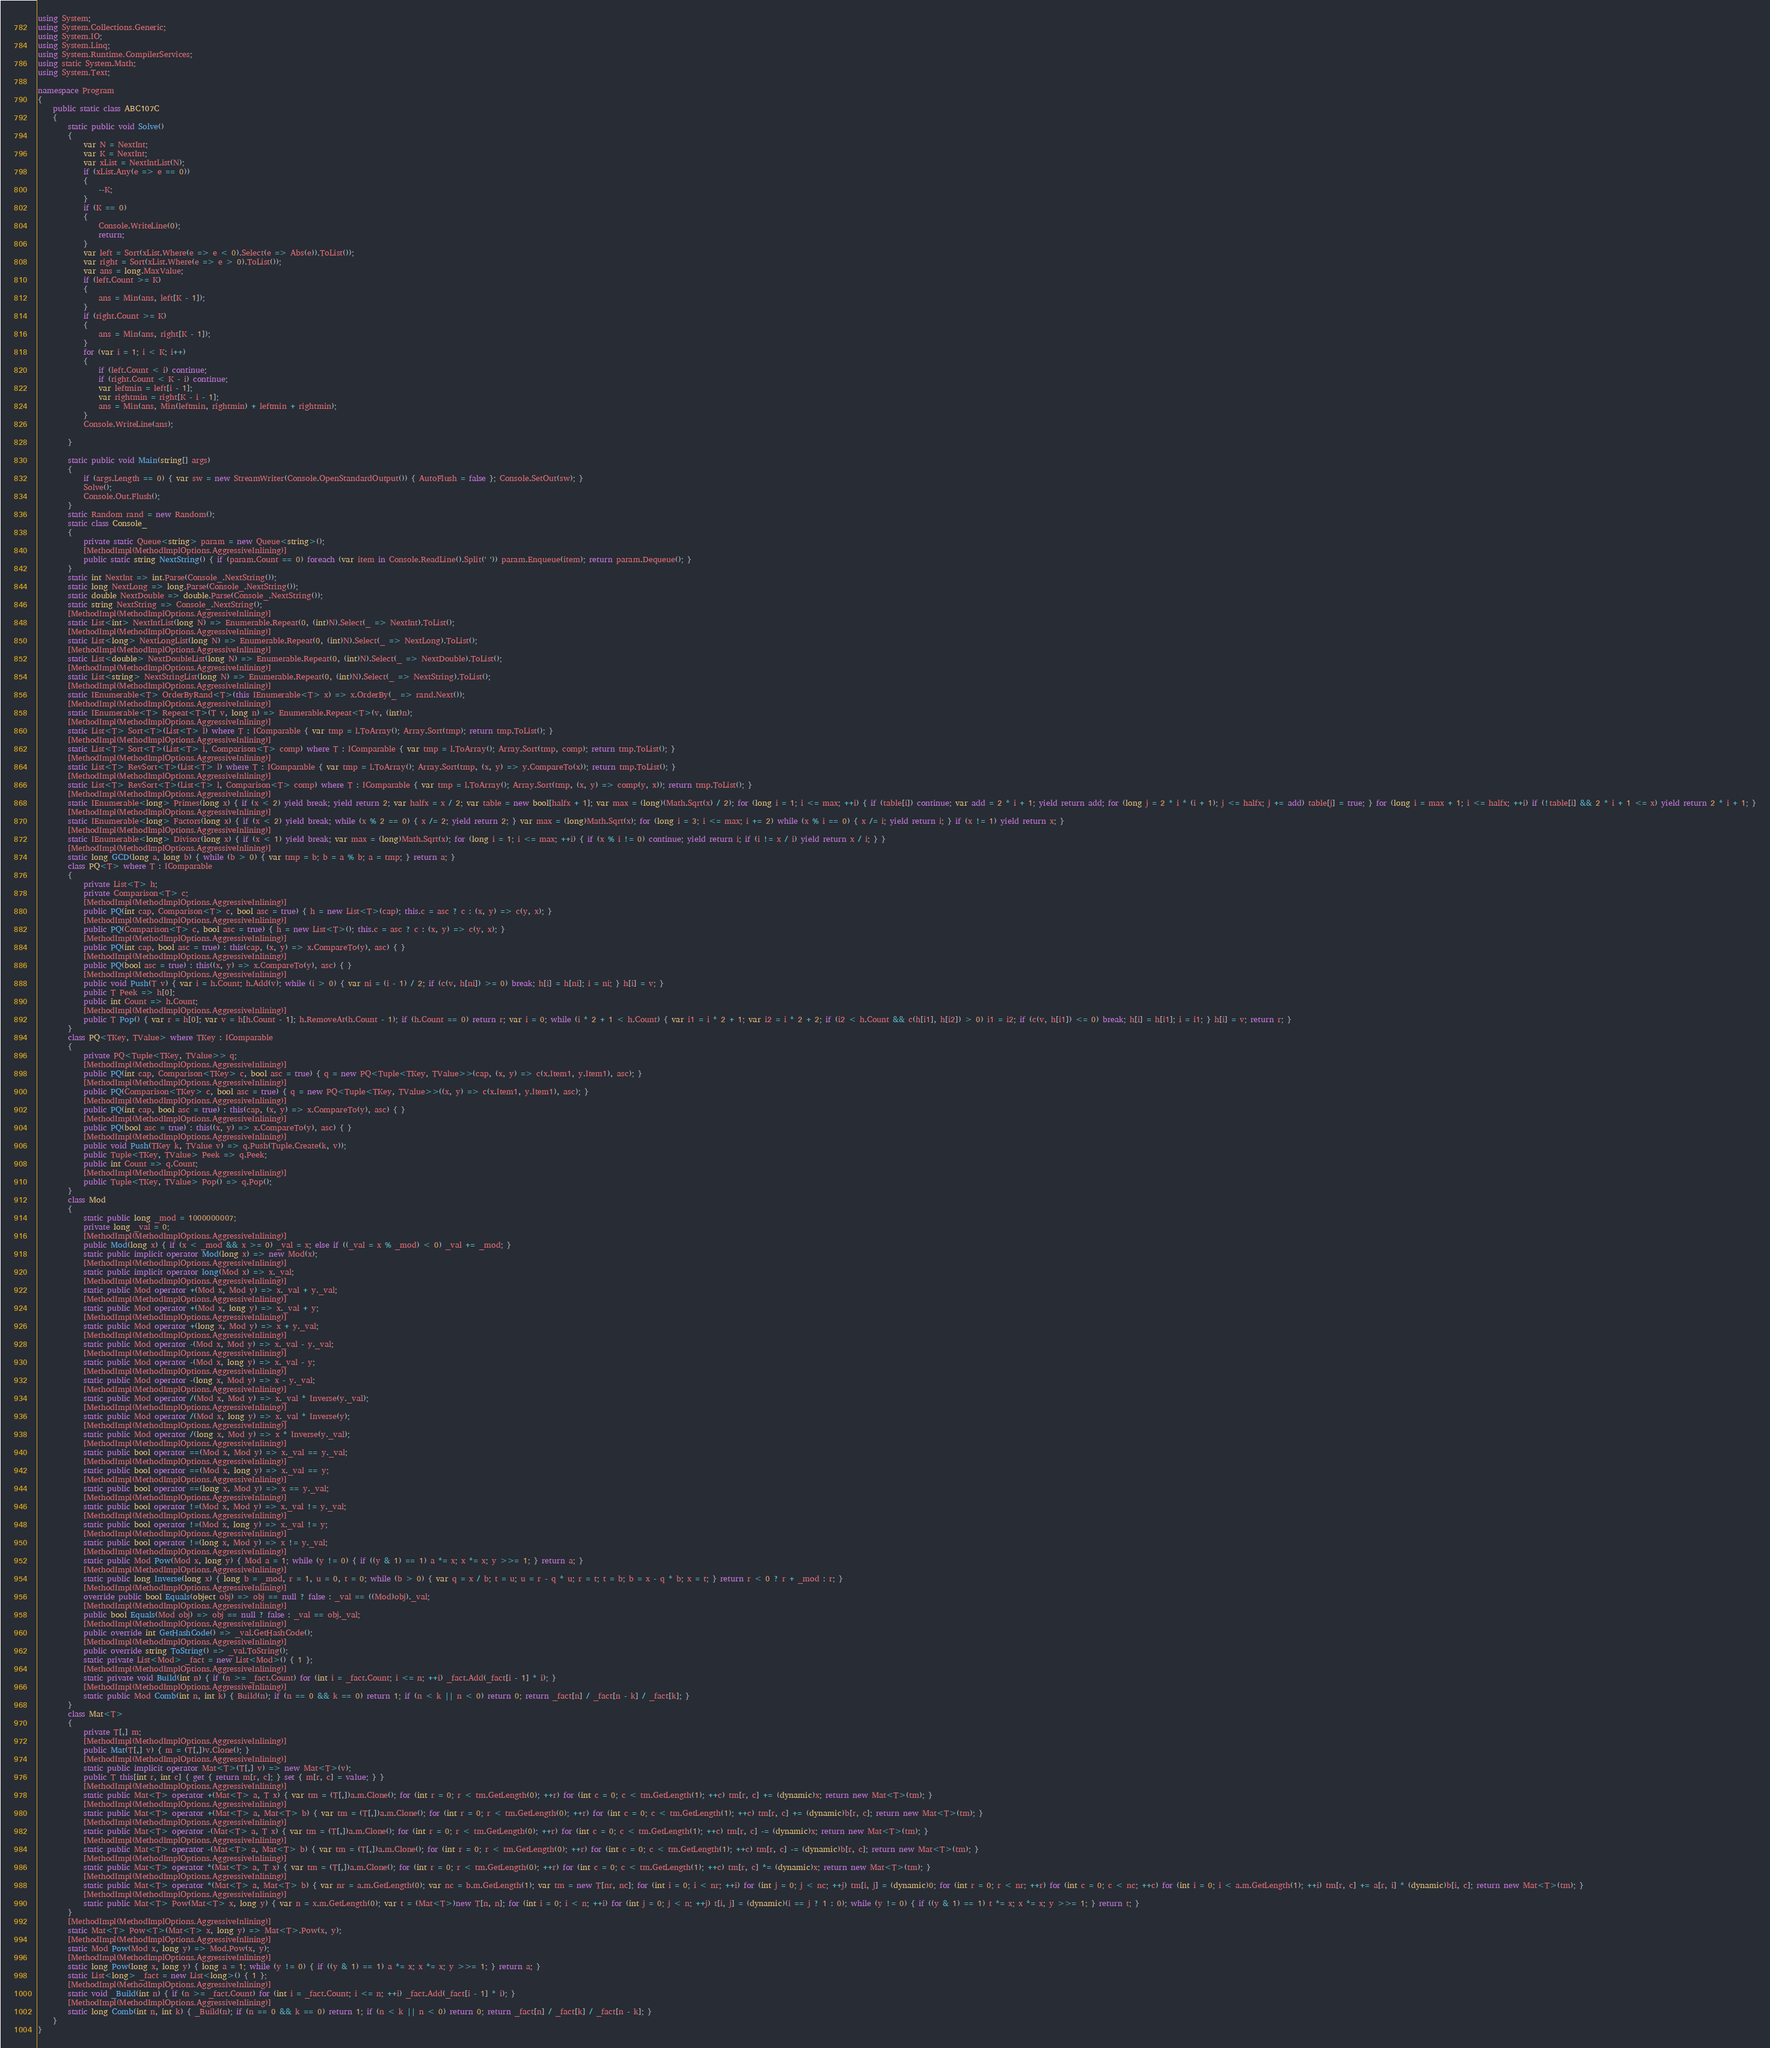Convert code to text. <code><loc_0><loc_0><loc_500><loc_500><_C#_>using System;
using System.Collections.Generic;
using System.IO;
using System.Linq;
using System.Runtime.CompilerServices;
using static System.Math;
using System.Text;

namespace Program
{
    public static class ABC107C
    {
        static public void Solve()
        {
            var N = NextInt;
            var K = NextInt;
            var xList = NextIntList(N);
            if (xList.Any(e => e == 0))
            {
                --K;
            }
            if (K == 0)
            {
                Console.WriteLine(0);
                return;
            }
            var left = Sort(xList.Where(e => e < 0).Select(e => Abs(e)).ToList());
            var right = Sort(xList.Where(e => e > 0).ToList());
            var ans = long.MaxValue;
            if (left.Count >= K)
            {
                ans = Min(ans, left[K - 1]);
            }
            if (right.Count >= K)
            {
                ans = Min(ans, right[K - 1]);
            }
            for (var i = 1; i < K; i++)
            {
                if (left.Count < i) continue;
                if (right.Count < K - i) continue;
                var leftmin = left[i - 1];
                var rightmin = right[K - i - 1];
                ans = Min(ans, Min(leftmin, rightmin) + leftmin + rightmin);
            }
            Console.WriteLine(ans);

        }

        static public void Main(string[] args)
        {
            if (args.Length == 0) { var sw = new StreamWriter(Console.OpenStandardOutput()) { AutoFlush = false }; Console.SetOut(sw); }
            Solve();
            Console.Out.Flush();
        }
        static Random rand = new Random();
        static class Console_
        {
            private static Queue<string> param = new Queue<string>();
            [MethodImpl(MethodImplOptions.AggressiveInlining)]
            public static string NextString() { if (param.Count == 0) foreach (var item in Console.ReadLine().Split(' ')) param.Enqueue(item); return param.Dequeue(); }
        }
        static int NextInt => int.Parse(Console_.NextString());
        static long NextLong => long.Parse(Console_.NextString());
        static double NextDouble => double.Parse(Console_.NextString());
        static string NextString => Console_.NextString();
        [MethodImpl(MethodImplOptions.AggressiveInlining)]
        static List<int> NextIntList(long N) => Enumerable.Repeat(0, (int)N).Select(_ => NextInt).ToList();
        [MethodImpl(MethodImplOptions.AggressiveInlining)]
        static List<long> NextLongList(long N) => Enumerable.Repeat(0, (int)N).Select(_ => NextLong).ToList();
        [MethodImpl(MethodImplOptions.AggressiveInlining)]
        static List<double> NextDoubleList(long N) => Enumerable.Repeat(0, (int)N).Select(_ => NextDouble).ToList();
        [MethodImpl(MethodImplOptions.AggressiveInlining)]
        static List<string> NextStringList(long N) => Enumerable.Repeat(0, (int)N).Select(_ => NextString).ToList();
        [MethodImpl(MethodImplOptions.AggressiveInlining)]
        static IEnumerable<T> OrderByRand<T>(this IEnumerable<T> x) => x.OrderBy(_ => rand.Next());
        [MethodImpl(MethodImplOptions.AggressiveInlining)]
        static IEnumerable<T> Repeat<T>(T v, long n) => Enumerable.Repeat<T>(v, (int)n);
        [MethodImpl(MethodImplOptions.AggressiveInlining)]
        static List<T> Sort<T>(List<T> l) where T : IComparable { var tmp = l.ToArray(); Array.Sort(tmp); return tmp.ToList(); }
        [MethodImpl(MethodImplOptions.AggressiveInlining)]
        static List<T> Sort<T>(List<T> l, Comparison<T> comp) where T : IComparable { var tmp = l.ToArray(); Array.Sort(tmp, comp); return tmp.ToList(); }
        [MethodImpl(MethodImplOptions.AggressiveInlining)]
        static List<T> RevSort<T>(List<T> l) where T : IComparable { var tmp = l.ToArray(); Array.Sort(tmp, (x, y) => y.CompareTo(x)); return tmp.ToList(); }
        [MethodImpl(MethodImplOptions.AggressiveInlining)]
        static List<T> RevSort<T>(List<T> l, Comparison<T> comp) where T : IComparable { var tmp = l.ToArray(); Array.Sort(tmp, (x, y) => comp(y, x)); return tmp.ToList(); }
        [MethodImpl(MethodImplOptions.AggressiveInlining)]
        static IEnumerable<long> Primes(long x) { if (x < 2) yield break; yield return 2; var halfx = x / 2; var table = new bool[halfx + 1]; var max = (long)(Math.Sqrt(x) / 2); for (long i = 1; i <= max; ++i) { if (table[i]) continue; var add = 2 * i + 1; yield return add; for (long j = 2 * i * (i + 1); j <= halfx; j += add) table[j] = true; } for (long i = max + 1; i <= halfx; ++i) if (!table[i] && 2 * i + 1 <= x) yield return 2 * i + 1; }
        [MethodImpl(MethodImplOptions.AggressiveInlining)]
        static IEnumerable<long> Factors(long x) { if (x < 2) yield break; while (x % 2 == 0) { x /= 2; yield return 2; } var max = (long)Math.Sqrt(x); for (long i = 3; i <= max; i += 2) while (x % i == 0) { x /= i; yield return i; } if (x != 1) yield return x; }
        [MethodImpl(MethodImplOptions.AggressiveInlining)]
        static IEnumerable<long> Divisor(long x) { if (x < 1) yield break; var max = (long)Math.Sqrt(x); for (long i = 1; i <= max; ++i) { if (x % i != 0) continue; yield return i; if (i != x / i) yield return x / i; } }
        [MethodImpl(MethodImplOptions.AggressiveInlining)]
        static long GCD(long a, long b) { while (b > 0) { var tmp = b; b = a % b; a = tmp; } return a; }
        class PQ<T> where T : IComparable
        {
            private List<T> h;
            private Comparison<T> c;
            [MethodImpl(MethodImplOptions.AggressiveInlining)]
            public PQ(int cap, Comparison<T> c, bool asc = true) { h = new List<T>(cap); this.c = asc ? c : (x, y) => c(y, x); }
            [MethodImpl(MethodImplOptions.AggressiveInlining)]
            public PQ(Comparison<T> c, bool asc = true) { h = new List<T>(); this.c = asc ? c : (x, y) => c(y, x); }
            [MethodImpl(MethodImplOptions.AggressiveInlining)]
            public PQ(int cap, bool asc = true) : this(cap, (x, y) => x.CompareTo(y), asc) { }
            [MethodImpl(MethodImplOptions.AggressiveInlining)]
            public PQ(bool asc = true) : this((x, y) => x.CompareTo(y), asc) { }
            [MethodImpl(MethodImplOptions.AggressiveInlining)]
            public void Push(T v) { var i = h.Count; h.Add(v); while (i > 0) { var ni = (i - 1) / 2; if (c(v, h[ni]) >= 0) break; h[i] = h[ni]; i = ni; } h[i] = v; }
            public T Peek => h[0];
            public int Count => h.Count;
            [MethodImpl(MethodImplOptions.AggressiveInlining)]
            public T Pop() { var r = h[0]; var v = h[h.Count - 1]; h.RemoveAt(h.Count - 1); if (h.Count == 0) return r; var i = 0; while (i * 2 + 1 < h.Count) { var i1 = i * 2 + 1; var i2 = i * 2 + 2; if (i2 < h.Count && c(h[i1], h[i2]) > 0) i1 = i2; if (c(v, h[i1]) <= 0) break; h[i] = h[i1]; i = i1; } h[i] = v; return r; }
        }
        class PQ<TKey, TValue> where TKey : IComparable
        {
            private PQ<Tuple<TKey, TValue>> q;
            [MethodImpl(MethodImplOptions.AggressiveInlining)]
            public PQ(int cap, Comparison<TKey> c, bool asc = true) { q = new PQ<Tuple<TKey, TValue>>(cap, (x, y) => c(x.Item1, y.Item1), asc); }
            [MethodImpl(MethodImplOptions.AggressiveInlining)]
            public PQ(Comparison<TKey> c, bool asc = true) { q = new PQ<Tuple<TKey, TValue>>((x, y) => c(x.Item1, y.Item1), asc); }
            [MethodImpl(MethodImplOptions.AggressiveInlining)]
            public PQ(int cap, bool asc = true) : this(cap, (x, y) => x.CompareTo(y), asc) { }
            [MethodImpl(MethodImplOptions.AggressiveInlining)]
            public PQ(bool asc = true) : this((x, y) => x.CompareTo(y), asc) { }
            [MethodImpl(MethodImplOptions.AggressiveInlining)]
            public void Push(TKey k, TValue v) => q.Push(Tuple.Create(k, v));
            public Tuple<TKey, TValue> Peek => q.Peek;
            public int Count => q.Count;
            [MethodImpl(MethodImplOptions.AggressiveInlining)]
            public Tuple<TKey, TValue> Pop() => q.Pop();
        }
        class Mod
        {
            static public long _mod = 1000000007;
            private long _val = 0;
            [MethodImpl(MethodImplOptions.AggressiveInlining)]
            public Mod(long x) { if (x < _mod && x >= 0) _val = x; else if ((_val = x % _mod) < 0) _val += _mod; }
            static public implicit operator Mod(long x) => new Mod(x);
            [MethodImpl(MethodImplOptions.AggressiveInlining)]
            static public implicit operator long(Mod x) => x._val;
            [MethodImpl(MethodImplOptions.AggressiveInlining)]
            static public Mod operator +(Mod x, Mod y) => x._val + y._val;
            [MethodImpl(MethodImplOptions.AggressiveInlining)]
            static public Mod operator +(Mod x, long y) => x._val + y;
            [MethodImpl(MethodImplOptions.AggressiveInlining)]
            static public Mod operator +(long x, Mod y) => x + y._val;
            [MethodImpl(MethodImplOptions.AggressiveInlining)]
            static public Mod operator -(Mod x, Mod y) => x._val - y._val;
            [MethodImpl(MethodImplOptions.AggressiveInlining)]
            static public Mod operator -(Mod x, long y) => x._val - y;
            [MethodImpl(MethodImplOptions.AggressiveInlining)]
            static public Mod operator -(long x, Mod y) => x - y._val;
            [MethodImpl(MethodImplOptions.AggressiveInlining)]
            static public Mod operator /(Mod x, Mod y) => x._val * Inverse(y._val);
            [MethodImpl(MethodImplOptions.AggressiveInlining)]
            static public Mod operator /(Mod x, long y) => x._val * Inverse(y);
            [MethodImpl(MethodImplOptions.AggressiveInlining)]
            static public Mod operator /(long x, Mod y) => x * Inverse(y._val);
            [MethodImpl(MethodImplOptions.AggressiveInlining)]
            static public bool operator ==(Mod x, Mod y) => x._val == y._val;
            [MethodImpl(MethodImplOptions.AggressiveInlining)]
            static public bool operator ==(Mod x, long y) => x._val == y;
            [MethodImpl(MethodImplOptions.AggressiveInlining)]
            static public bool operator ==(long x, Mod y) => x == y._val;
            [MethodImpl(MethodImplOptions.AggressiveInlining)]
            static public bool operator !=(Mod x, Mod y) => x._val != y._val;
            [MethodImpl(MethodImplOptions.AggressiveInlining)]
            static public bool operator !=(Mod x, long y) => x._val != y;
            [MethodImpl(MethodImplOptions.AggressiveInlining)]
            static public bool operator !=(long x, Mod y) => x != y._val;
            [MethodImpl(MethodImplOptions.AggressiveInlining)]
            static public Mod Pow(Mod x, long y) { Mod a = 1; while (y != 0) { if ((y & 1) == 1) a *= x; x *= x; y >>= 1; } return a; }
            [MethodImpl(MethodImplOptions.AggressiveInlining)]
            static public long Inverse(long x) { long b = _mod, r = 1, u = 0, t = 0; while (b > 0) { var q = x / b; t = u; u = r - q * u; r = t; t = b; b = x - q * b; x = t; } return r < 0 ? r + _mod : r; }
            [MethodImpl(MethodImplOptions.AggressiveInlining)]
            override public bool Equals(object obj) => obj == null ? false : _val == ((Mod)obj)._val;
            [MethodImpl(MethodImplOptions.AggressiveInlining)]
            public bool Equals(Mod obj) => obj == null ? false : _val == obj._val;
            [MethodImpl(MethodImplOptions.AggressiveInlining)]
            public override int GetHashCode() => _val.GetHashCode();
            [MethodImpl(MethodImplOptions.AggressiveInlining)]
            public override string ToString() => _val.ToString();
            static private List<Mod> _fact = new List<Mod>() { 1 };
            [MethodImpl(MethodImplOptions.AggressiveInlining)]
            static private void Build(int n) { if (n >= _fact.Count) for (int i = _fact.Count; i <= n; ++i) _fact.Add(_fact[i - 1] * i); }
            [MethodImpl(MethodImplOptions.AggressiveInlining)]
            static public Mod Comb(int n, int k) { Build(n); if (n == 0 && k == 0) return 1; if (n < k || n < 0) return 0; return _fact[n] / _fact[n - k] / _fact[k]; }
        }
        class Mat<T>
        {
            private T[,] m;
            [MethodImpl(MethodImplOptions.AggressiveInlining)]
            public Mat(T[,] v) { m = (T[,])v.Clone(); }
            [MethodImpl(MethodImplOptions.AggressiveInlining)]
            static public implicit operator Mat<T>(T[,] v) => new Mat<T>(v);
            public T this[int r, int c] { get { return m[r, c]; } set { m[r, c] = value; } }
            [MethodImpl(MethodImplOptions.AggressiveInlining)]
            static public Mat<T> operator +(Mat<T> a, T x) { var tm = (T[,])a.m.Clone(); for (int r = 0; r < tm.GetLength(0); ++r) for (int c = 0; c < tm.GetLength(1); ++c) tm[r, c] += (dynamic)x; return new Mat<T>(tm); }
            [MethodImpl(MethodImplOptions.AggressiveInlining)]
            static public Mat<T> operator +(Mat<T> a, Mat<T> b) { var tm = (T[,])a.m.Clone(); for (int r = 0; r < tm.GetLength(0); ++r) for (int c = 0; c < tm.GetLength(1); ++c) tm[r, c] += (dynamic)b[r, c]; return new Mat<T>(tm); }
            [MethodImpl(MethodImplOptions.AggressiveInlining)]
            static public Mat<T> operator -(Mat<T> a, T x) { var tm = (T[,])a.m.Clone(); for (int r = 0; r < tm.GetLength(0); ++r) for (int c = 0; c < tm.GetLength(1); ++c) tm[r, c] -= (dynamic)x; return new Mat<T>(tm); }
            [MethodImpl(MethodImplOptions.AggressiveInlining)]
            static public Mat<T> operator -(Mat<T> a, Mat<T> b) { var tm = (T[,])a.m.Clone(); for (int r = 0; r < tm.GetLength(0); ++r) for (int c = 0; c < tm.GetLength(1); ++c) tm[r, c] -= (dynamic)b[r, c]; return new Mat<T>(tm); }
            [MethodImpl(MethodImplOptions.AggressiveInlining)]
            static public Mat<T> operator *(Mat<T> a, T x) { var tm = (T[,])a.m.Clone(); for (int r = 0; r < tm.GetLength(0); ++r) for (int c = 0; c < tm.GetLength(1); ++c) tm[r, c] *= (dynamic)x; return new Mat<T>(tm); }
            [MethodImpl(MethodImplOptions.AggressiveInlining)]
            static public Mat<T> operator *(Mat<T> a, Mat<T> b) { var nr = a.m.GetLength(0); var nc = b.m.GetLength(1); var tm = new T[nr, nc]; for (int i = 0; i < nr; ++i) for (int j = 0; j < nc; ++j) tm[i, j] = (dynamic)0; for (int r = 0; r < nr; ++r) for (int c = 0; c < nc; ++c) for (int i = 0; i < a.m.GetLength(1); ++i) tm[r, c] += a[r, i] * (dynamic)b[i, c]; return new Mat<T>(tm); }
            [MethodImpl(MethodImplOptions.AggressiveInlining)]
            static public Mat<T> Pow(Mat<T> x, long y) { var n = x.m.GetLength(0); var t = (Mat<T>)new T[n, n]; for (int i = 0; i < n; ++i) for (int j = 0; j < n; ++j) t[i, j] = (dynamic)(i == j ? 1 : 0); while (y != 0) { if ((y & 1) == 1) t *= x; x *= x; y >>= 1; } return t; }
        }
        [MethodImpl(MethodImplOptions.AggressiveInlining)]
        static Mat<T> Pow<T>(Mat<T> x, long y) => Mat<T>.Pow(x, y);
        [MethodImpl(MethodImplOptions.AggressiveInlining)]
        static Mod Pow(Mod x, long y) => Mod.Pow(x, y);
        [MethodImpl(MethodImplOptions.AggressiveInlining)]
        static long Pow(long x, long y) { long a = 1; while (y != 0) { if ((y & 1) == 1) a *= x; x *= x; y >>= 1; } return a; }
        static List<long> _fact = new List<long>() { 1 };
        [MethodImpl(MethodImplOptions.AggressiveInlining)]
        static void _Build(int n) { if (n >= _fact.Count) for (int i = _fact.Count; i <= n; ++i) _fact.Add(_fact[i - 1] * i); }
        [MethodImpl(MethodImplOptions.AggressiveInlining)]
        static long Comb(int n, int k) { _Build(n); if (n == 0 && k == 0) return 1; if (n < k || n < 0) return 0; return _fact[n] / _fact[k] / _fact[n - k]; }
    }
}
</code> 